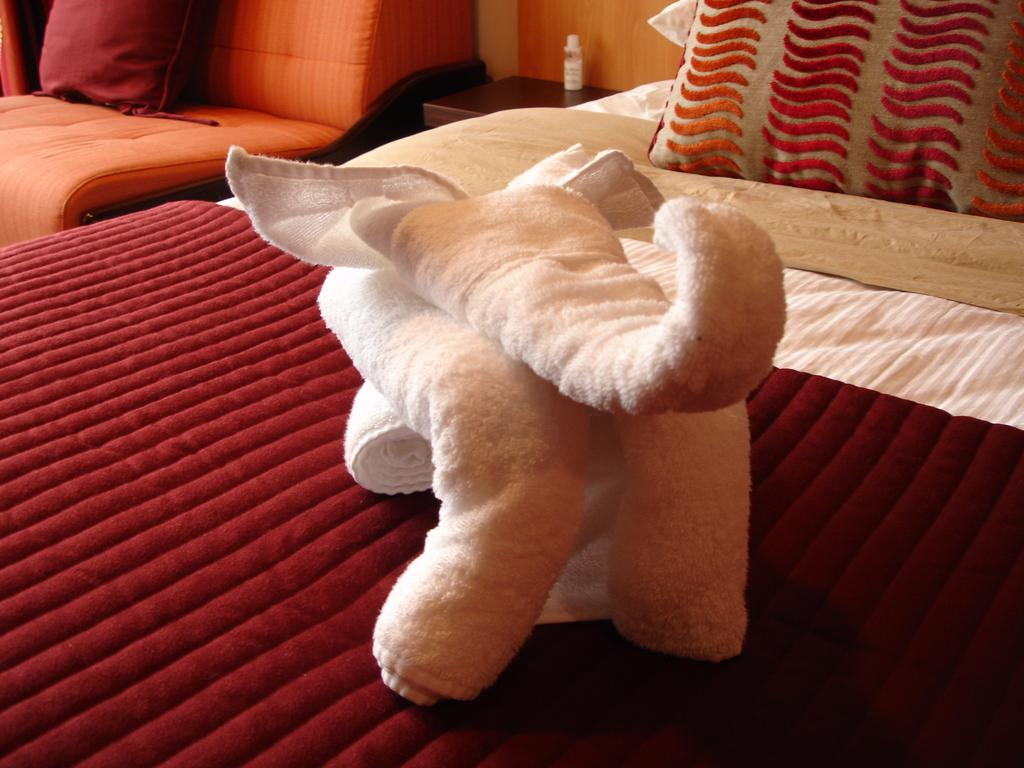What type of furniture is present in the image? There is a bed and a sofa in the image. What is placed on the bed? There is a blanket, a pillow, and a towel on the bed. Can you describe the arrangement of the furniture in the image? The bed and the sofa are placed beside each other. What type of grass is growing on the sofa in the image? There is no grass present on the sofa or in the image. 